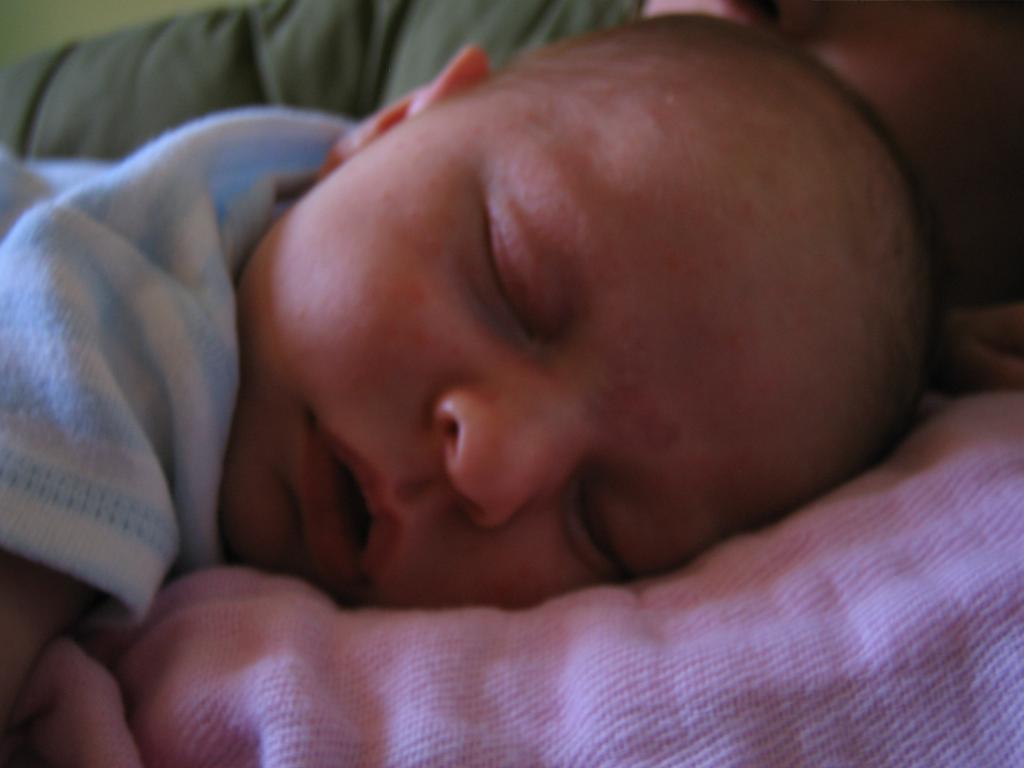In one or two sentences, can you explain what this image depicts? In the image we can see there is an infant sleeping on the bed sheet. 